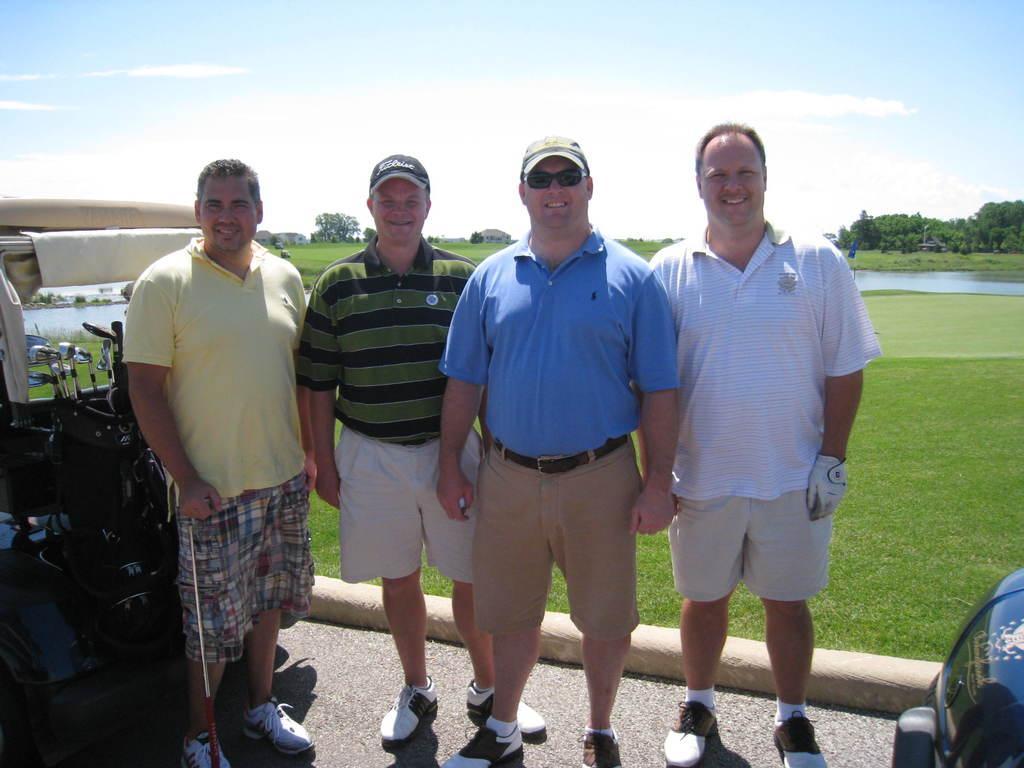Can you describe this image briefly? In this image I can see four persons standing and I can also see few objects. In the background I can see the water, few trees in green color and the sky is in blue and white color. 